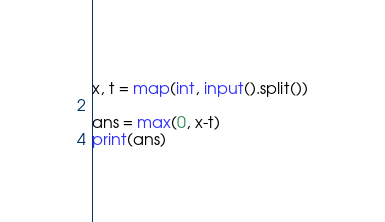<code> <loc_0><loc_0><loc_500><loc_500><_Python_>x, t = map(int, input().split())

ans = max(0, x-t)
print(ans)</code> 